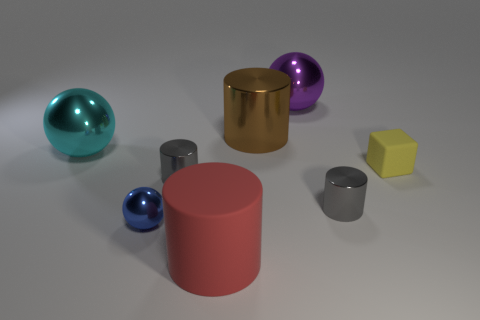What is the gray cylinder that is to the left of the purple metallic object made of?
Provide a short and direct response. Metal. Are there an equal number of red cylinders in front of the tiny yellow matte object and big purple metal balls that are in front of the red matte thing?
Provide a short and direct response. No. Do the gray shiny object that is to the right of the large purple ball and the blue metallic sphere in front of the big cyan metal sphere have the same size?
Offer a very short reply. Yes. What number of large cylinders are the same color as the tiny matte object?
Make the answer very short. 0. Is the number of large brown shiny cylinders on the right side of the tiny yellow matte block greater than the number of tiny cylinders?
Keep it short and to the point. No. Do the small matte thing and the purple object have the same shape?
Your answer should be compact. No. What number of yellow objects are the same material as the red cylinder?
Your answer should be compact. 1. What size is the purple thing that is the same shape as the blue shiny object?
Your response must be concise. Large. Do the blue shiny sphere and the cyan shiny sphere have the same size?
Your response must be concise. No. What shape is the tiny thing that is in front of the tiny metal thing that is on the right side of the cylinder in front of the blue thing?
Provide a short and direct response. Sphere. 